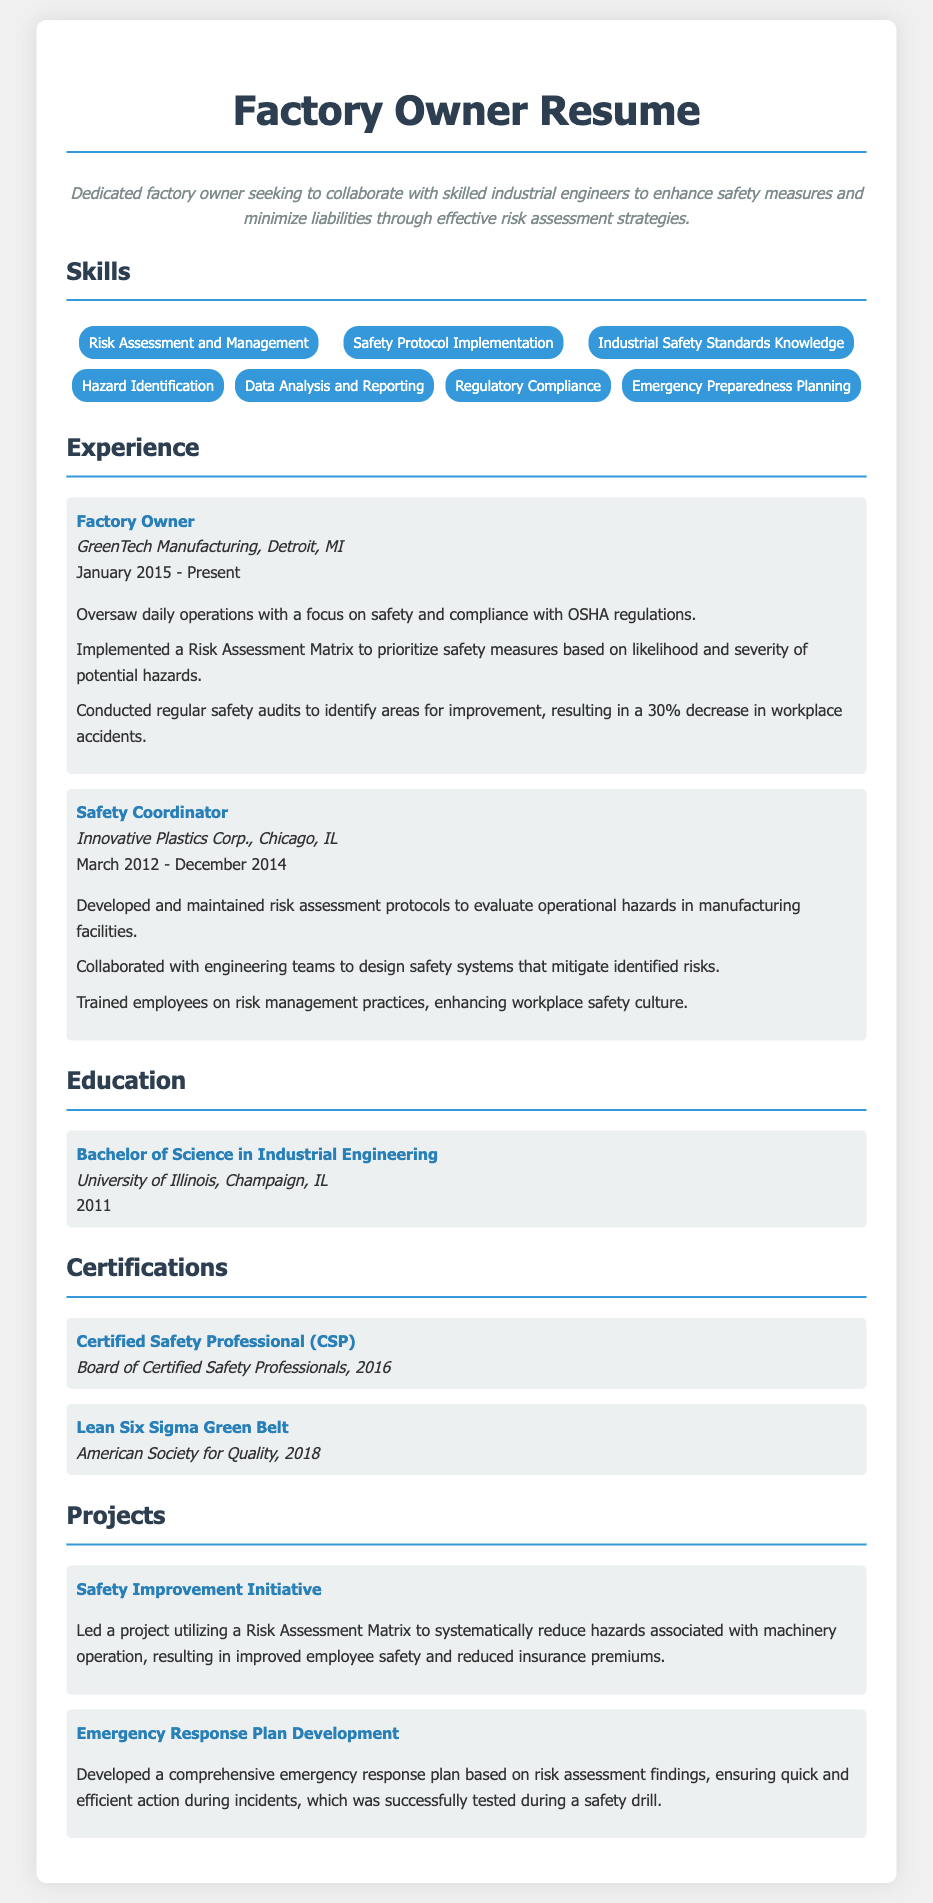What is the name of the current employer? The current employer is mentioned in the professional experience section of the resume, which states "GreenTech Manufacturing."
Answer: GreenTech Manufacturing When did the person become a factory owner? The starting date of the Factory Owner position is listed in the experience section, which is "January 2015."
Answer: January 2015 What percentage decrease in workplace accidents was achieved? The resume mentions a "30% decrease in workplace accidents" as part of the outcomes of safety audits.
Answer: 30% What certification was obtained in 2016? The resume lists "Certified Safety Professional (CSP)" as a certification acquired in 2016.
Answer: Certified Safety Professional (CSP) What project focused on reducing hazards associated with machinery? The project name listed in the projects section is "Safety Improvement Initiative," which addresses this concern.
Answer: Safety Improvement Initiative How many years did the person work as a Safety Coordinator? By subtracting the start date from the end date provided in the experience section, we calculate the time span from March 2012 to December 2014, which is approximately 2 years and 9 months.
Answer: 2 years 9 months What degree was earned at the University of Illinois? The education section states that a "Bachelor of Science in Industrial Engineering" was obtained from this institution.
Answer: Bachelor of Science in Industrial Engineering What is one of the skills listed related to emergency planning? Among the skills listed, "Emergency Preparedness Planning" is specified.
Answer: Emergency Preparedness Planning Which organization awarded the Lean Six Sigma certification? The certification section clearly indicates that the "American Society for Quality" is the organization that awarded this certification.
Answer: American Society for Quality 